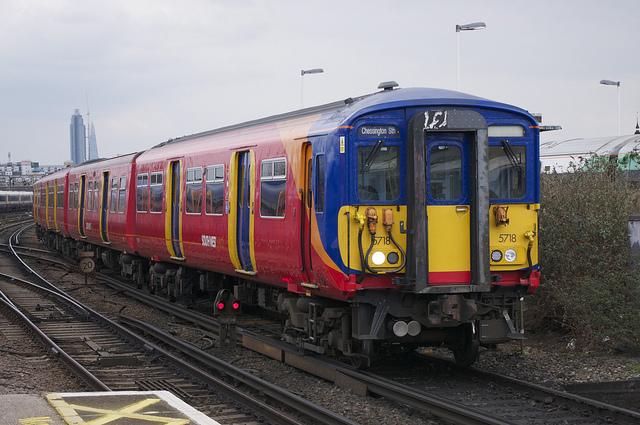Is this train going through a tunnel?
Write a very short answer. No. What color is the train?
Keep it brief. Red. Are the trains lights on?
Be succinct. Yes. What color lights are on the front of the train?
Quick response, please. Yellow. Does the train have polka dots?
Short answer required. No. What # is the train?
Keep it brief. 5718. 